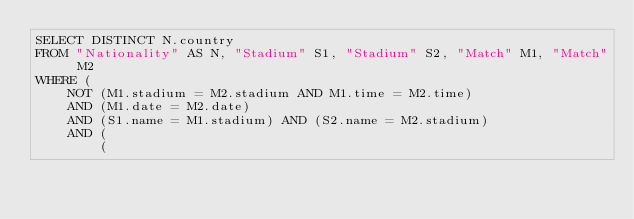<code> <loc_0><loc_0><loc_500><loc_500><_SQL_>SELECT DISTINCT N.country
FROM "Nationality" AS N, "Stadium" S1, "Stadium" S2, "Match" M1, "Match" M2
WHERE (
	NOT (M1.stadium = M2.stadium AND M1.time = M2.time)
	AND (M1.date = M2.date)
	AND (S1.name = M1.stadium) AND (S2.name = M2.stadium)
	AND (
		(</code> 